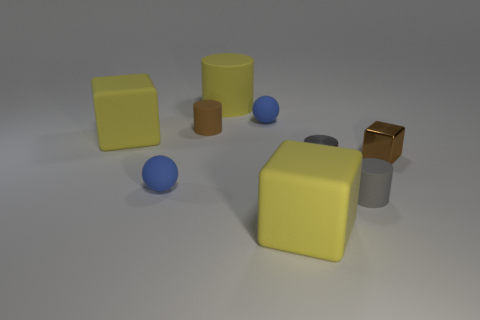Are there any large brown cubes that have the same material as the tiny brown cylinder?
Ensure brevity in your answer.  No. Are there any other things that have the same material as the tiny brown cube?
Provide a short and direct response. Yes. The metallic block has what color?
Your answer should be compact. Brown. There is a small thing that is the same color as the small metallic block; what is its shape?
Your response must be concise. Cylinder. The metal cube that is the same size as the brown cylinder is what color?
Your response must be concise. Brown. What number of matte things are small brown cylinders or tiny objects?
Offer a very short reply. 4. How many things are both in front of the big cylinder and on the left side of the tiny brown shiny block?
Keep it short and to the point. 7. Are there any other things that are the same shape as the brown rubber thing?
Offer a terse response. Yes. What number of other objects are there of the same size as the gray rubber cylinder?
Your response must be concise. 5. Does the blue matte ball behind the brown cube have the same size as the brown thing right of the yellow cylinder?
Keep it short and to the point. Yes. 